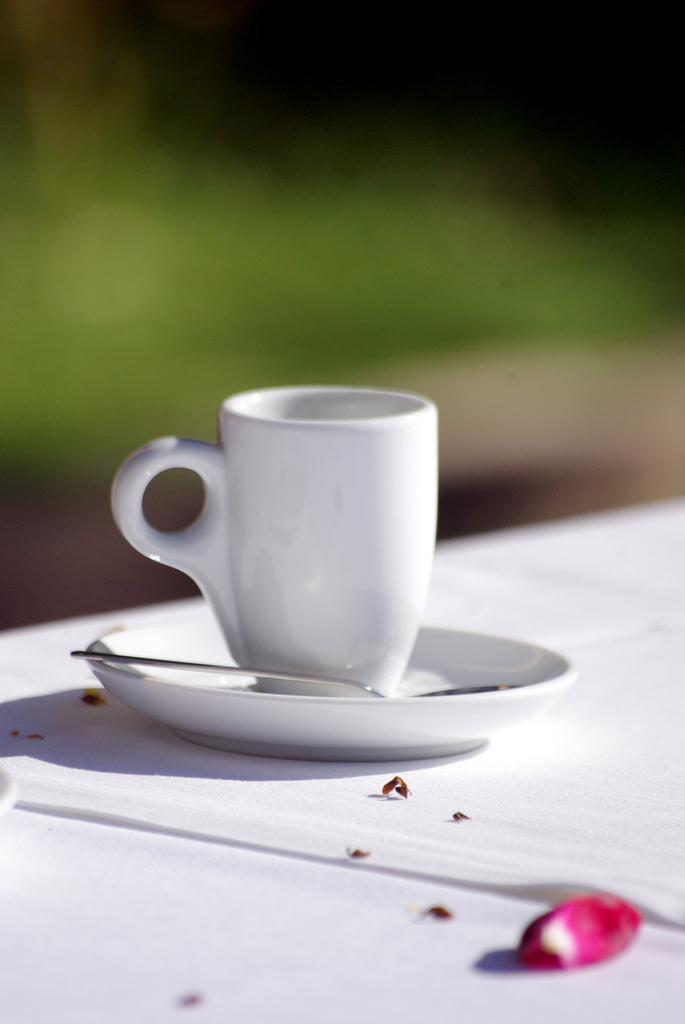What is the main object in the image? There is a teacup in the image. What is the teacup resting on? The teacup has a saucer. What utensil is present in the image? There is a spoon in the image. Where are the teacup, saucer, and spoon located? They are on a table. What direction is the actor facing in the image? There is no actor present in the image; it features a teacup, saucer, and spoon on a table. 